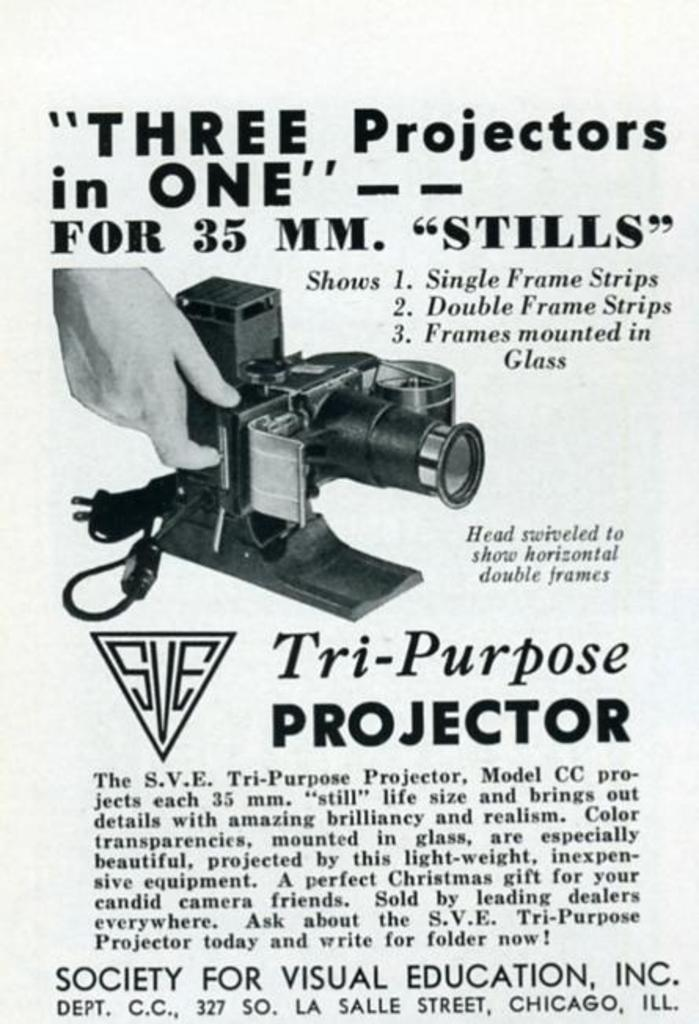<image>
Offer a succinct explanation of the picture presented. A black and white ad for a Tri-Purpose Projector. 